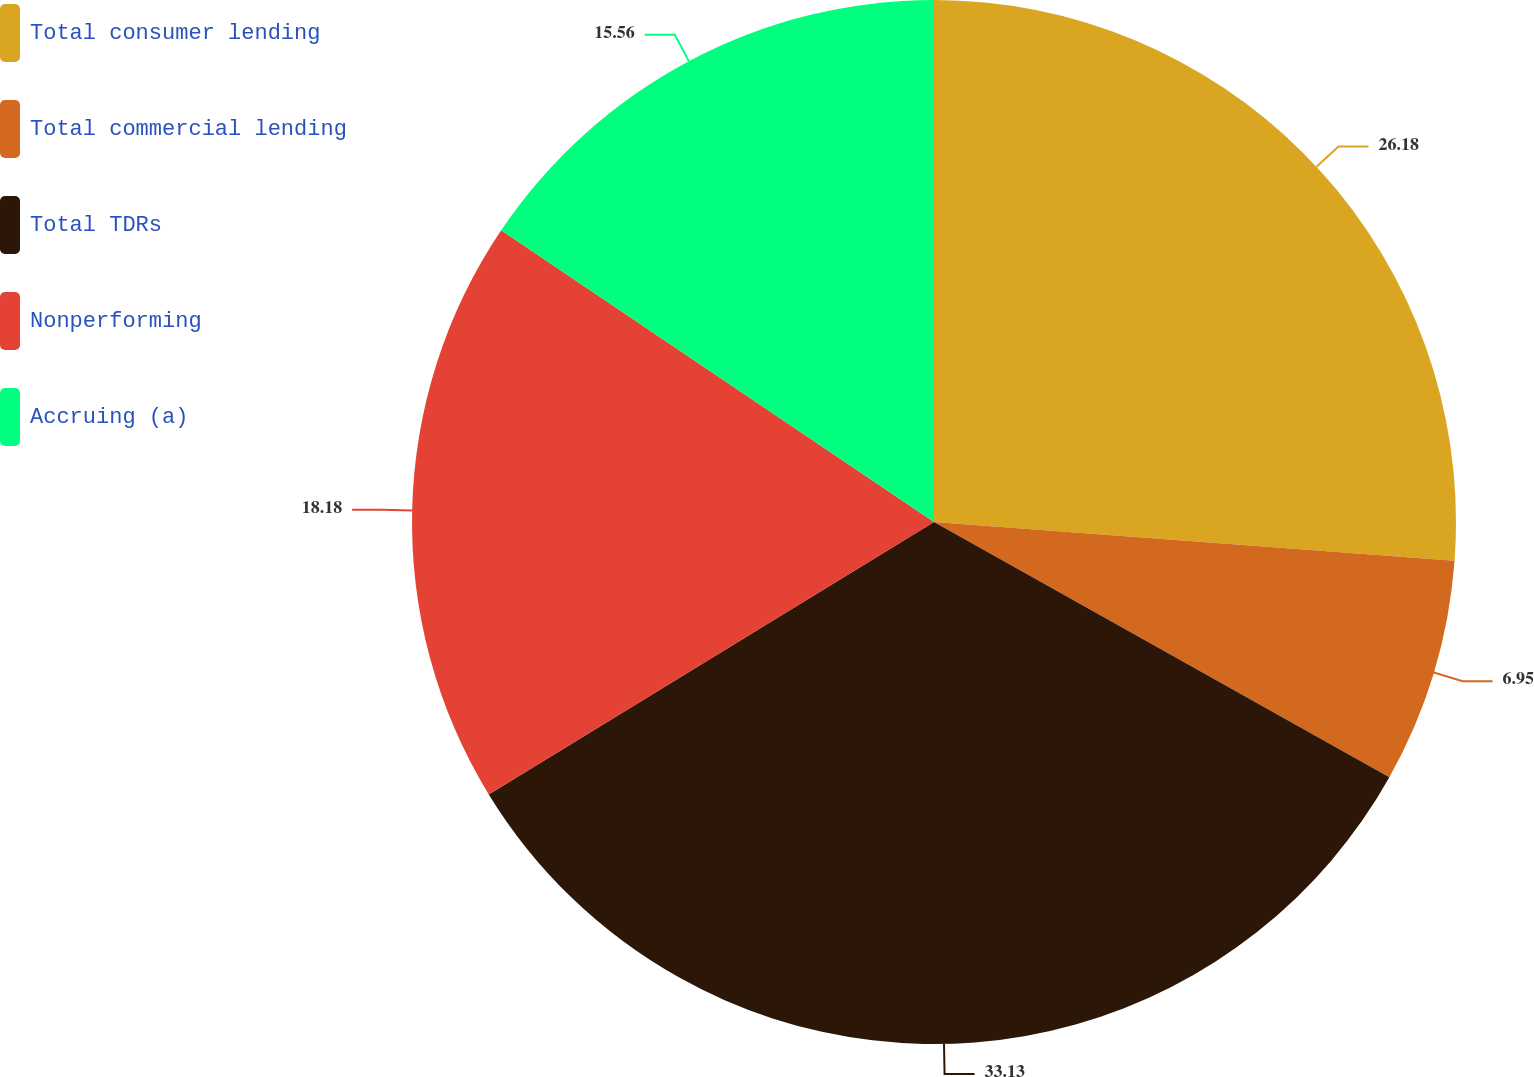Convert chart to OTSL. <chart><loc_0><loc_0><loc_500><loc_500><pie_chart><fcel>Total consumer lending<fcel>Total commercial lending<fcel>Total TDRs<fcel>Nonperforming<fcel>Accruing (a)<nl><fcel>26.18%<fcel>6.95%<fcel>33.13%<fcel>18.18%<fcel>15.56%<nl></chart> 